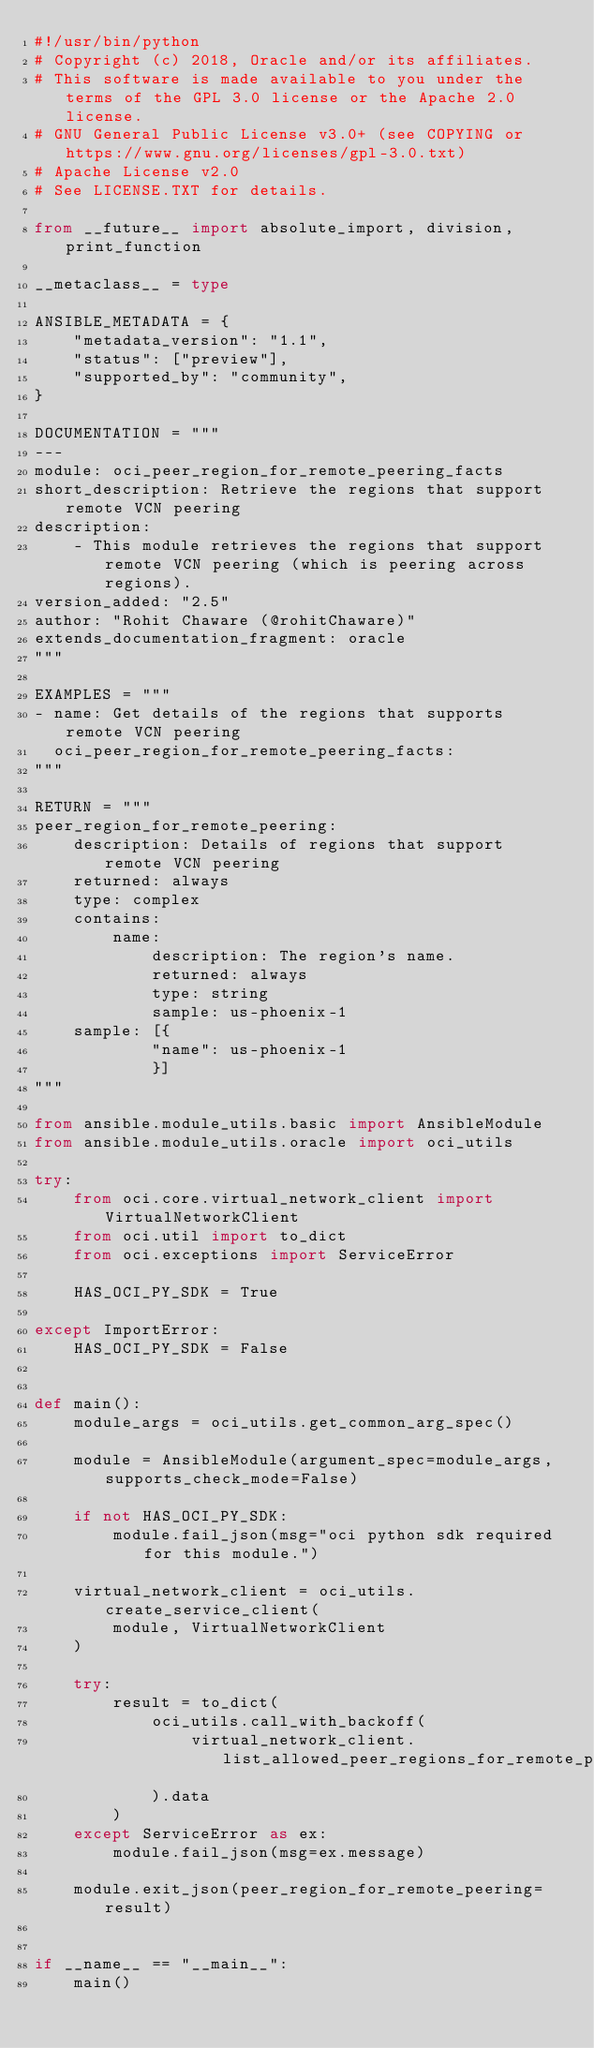Convert code to text. <code><loc_0><loc_0><loc_500><loc_500><_Python_>#!/usr/bin/python
# Copyright (c) 2018, Oracle and/or its affiliates.
# This software is made available to you under the terms of the GPL 3.0 license or the Apache 2.0 license.
# GNU General Public License v3.0+ (see COPYING or https://www.gnu.org/licenses/gpl-3.0.txt)
# Apache License v2.0
# See LICENSE.TXT for details.

from __future__ import absolute_import, division, print_function

__metaclass__ = type

ANSIBLE_METADATA = {
    "metadata_version": "1.1",
    "status": ["preview"],
    "supported_by": "community",
}

DOCUMENTATION = """
---
module: oci_peer_region_for_remote_peering_facts
short_description: Retrieve the regions that support remote VCN peering
description:
    - This module retrieves the regions that support remote VCN peering (which is peering across regions).
version_added: "2.5"
author: "Rohit Chaware (@rohitChaware)"
extends_documentation_fragment: oracle
"""

EXAMPLES = """
- name: Get details of the regions that supports remote VCN peering
  oci_peer_region_for_remote_peering_facts:
"""

RETURN = """
peer_region_for_remote_peering:
    description: Details of regions that support remote VCN peering
    returned: always
    type: complex
    contains:
        name:
            description: The region's name.
            returned: always
            type: string
            sample: us-phoenix-1
    sample: [{
            "name": us-phoenix-1
            }]
"""

from ansible.module_utils.basic import AnsibleModule
from ansible.module_utils.oracle import oci_utils

try:
    from oci.core.virtual_network_client import VirtualNetworkClient
    from oci.util import to_dict
    from oci.exceptions import ServiceError

    HAS_OCI_PY_SDK = True

except ImportError:
    HAS_OCI_PY_SDK = False


def main():
    module_args = oci_utils.get_common_arg_spec()

    module = AnsibleModule(argument_spec=module_args, supports_check_mode=False)

    if not HAS_OCI_PY_SDK:
        module.fail_json(msg="oci python sdk required for this module.")

    virtual_network_client = oci_utils.create_service_client(
        module, VirtualNetworkClient
    )

    try:
        result = to_dict(
            oci_utils.call_with_backoff(
                virtual_network_client.list_allowed_peer_regions_for_remote_peering
            ).data
        )
    except ServiceError as ex:
        module.fail_json(msg=ex.message)

    module.exit_json(peer_region_for_remote_peering=result)


if __name__ == "__main__":
    main()
</code> 